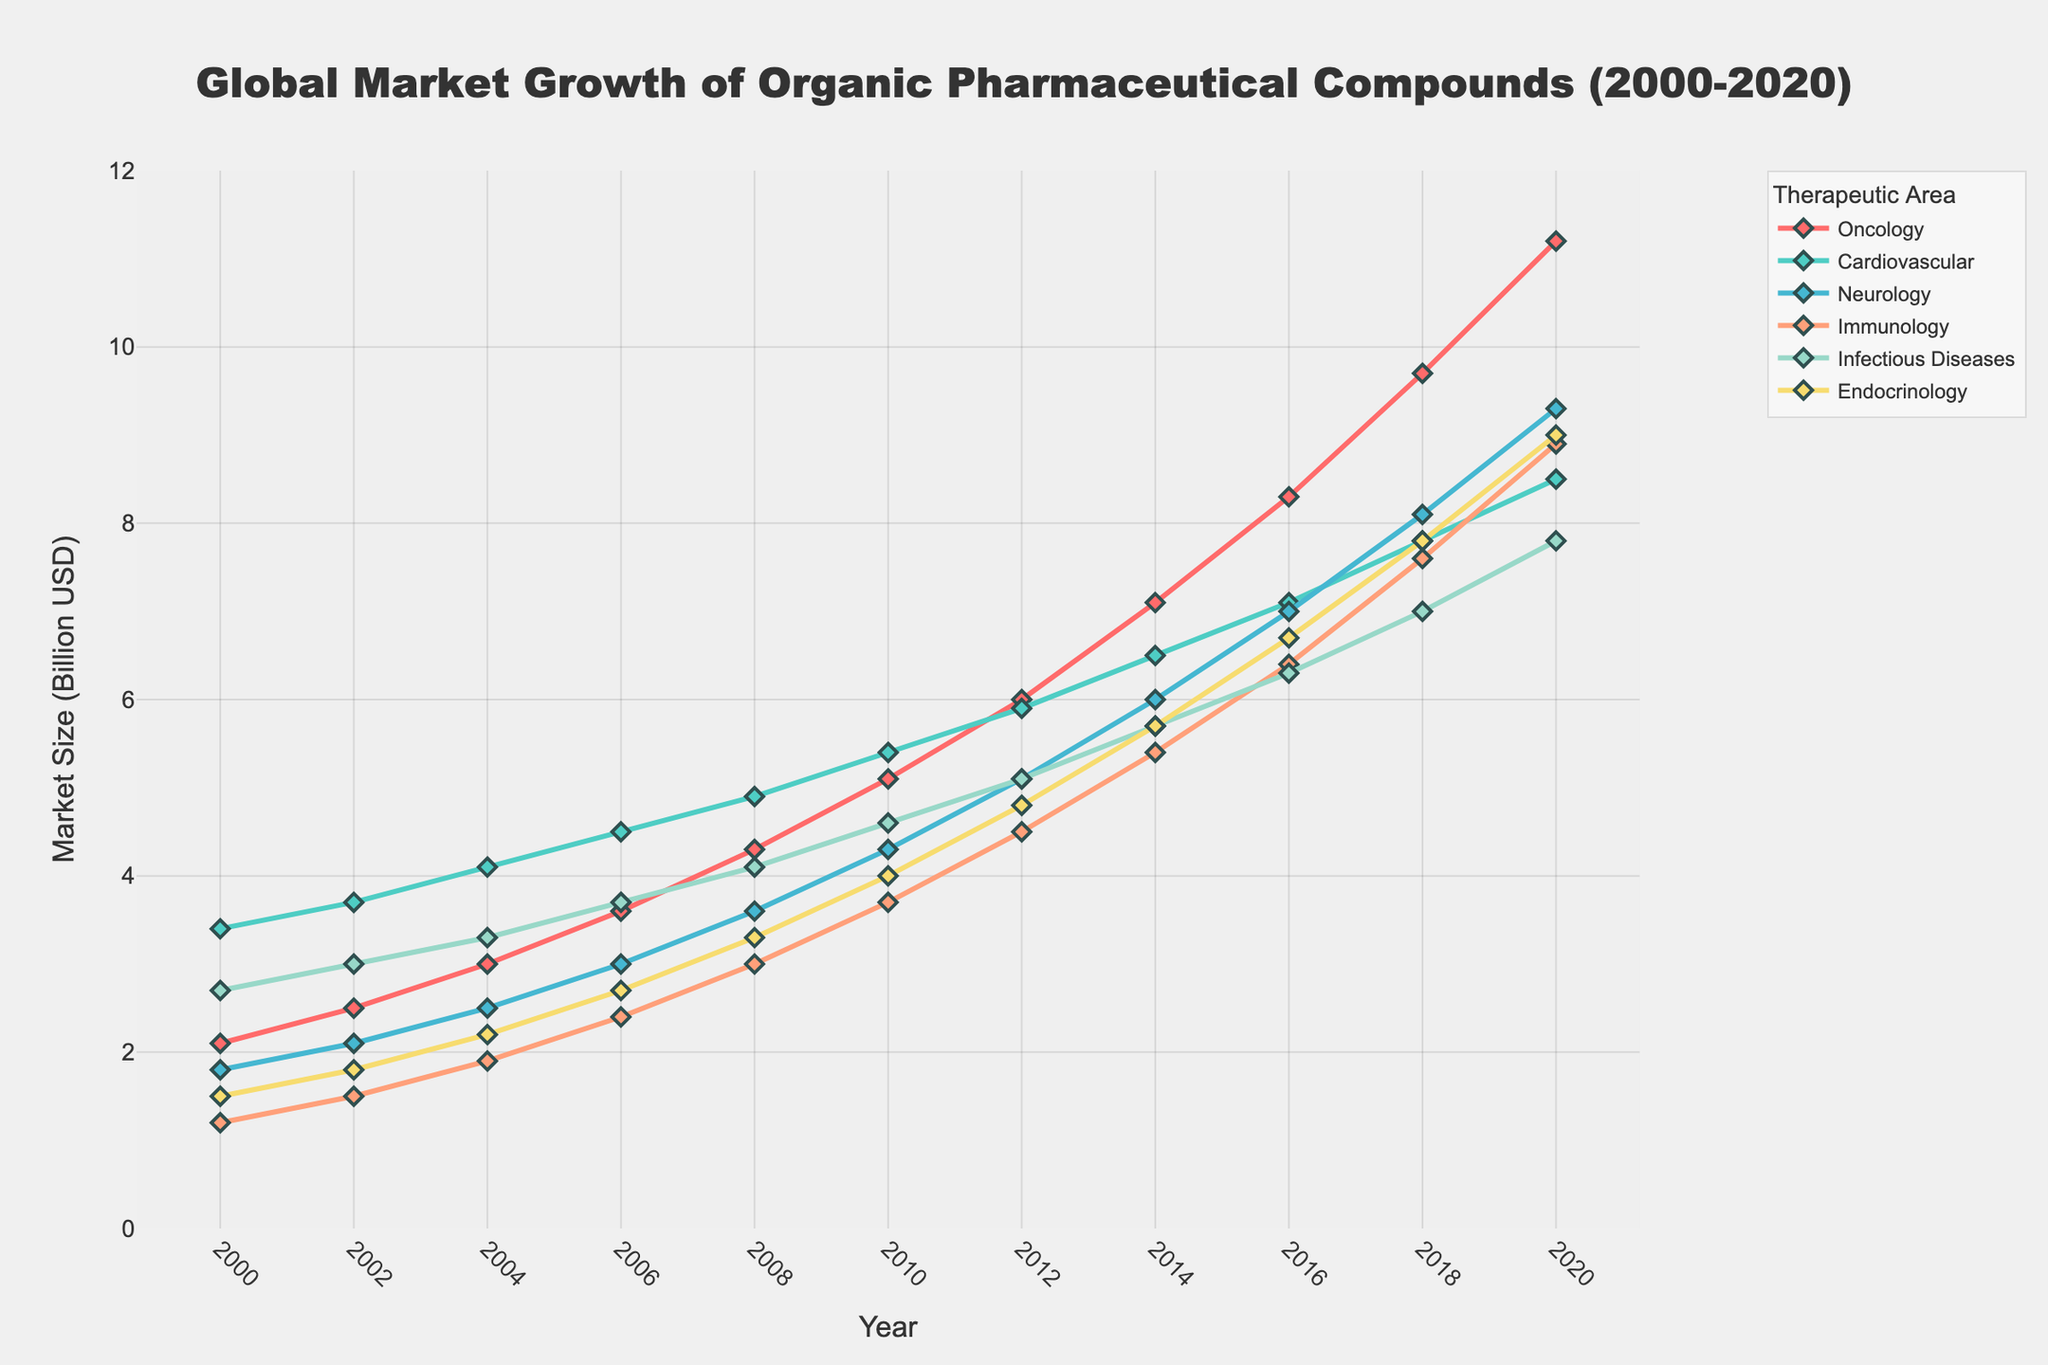What's the overall trend in the market size for Oncology from 2000 to 2020? The market size for Oncology shows a continuous upward trend from 2.1 billion USD in 2000 to 11.2 billion USD in 2020. This indicates a consistent growth over the 20 years.
Answer: Continuous upward trend Which therapeutic area had the lowest market size in 2010? By examining the figure, Immunology had the lowest market size in 2010 among all the therapeutic areas, with a value of 3.7 billion USD.
Answer: Immunology How does the growth rate of Cardiovascular compare to that of Neurology from 2000 to 2020? The market size for Cardiovascular increased from 3.4 billion USD in 2000 to 8.5 billion USD in 2020, while Neurology increased from 1.8 billion USD to 9.3 billion USD in the same period. Neurology's growth rate is higher than Cardiovascular's.
Answer: Neurology's growth rate is higher Which therapeutic area had the most significant increase in market size between 2000 and 2020? Oncology showed the most significant increase in market size, rising from 2.1 billion USD in 2000 to 11.2 billion USD in 2020. The increase is 9.1 billion USD over the period.
Answer: Oncology Which therapeutic area had the lowest market size increase from 2000 to 2020? Endocrinology had the lowest market size increase, growing from 1.5 billion USD in 2000 to 9.0 billion USD in 2020. The increase is 7.5 billion USD over the period.
Answer: Endocrinology What is the visual pattern of the market size for Infectious Diseases from 2000 to 2020? The market size for Infectious Diseases shows a consistent upward trend, starting at 2.7 billion USD in 2000 and increasing to 7.8 billion USD in 2020. The growth is relatively steady over the period.
Answer: Consistent upward trend Compare the market sizes for Immunology and Cardiovascular in 2016. Which one is greater and by how much? In 2016, the market size for Immunology is 6.4 billion USD and for Cardiovascular is 7.1 billion USD. Cardiovascular is greater by 0.7 billion USD.
Answer: Cardiovascular by 0.7 billion USD What is the average market size for Neurology from 2000 to 2020? The market sizes for Neurology from 2000 to 2020 are 1.8, 2.1, 2.5, 3.0, 3.6, 4.3, 5.1, 6.0, 7.0, 8.1, and 9.3 billion USD. The sum is 52.8 billion USD over 11 data points, so the average is 52.8 / 11 = 4.8 billion USD.
Answer: 4.8 billion USD In 2020, which therapeutic area had the second highest market size, and what was the value? In 2020, the second highest market size was for Neurology, with a value of 9.3 billion USD, after Oncology.
Answer: Neurology, 9.3 billion USD How much did the market size for Endocrinology grow from 2008 to 2014? The market size for Endocrinology grew from 3.3 billion USD in 2008 to 5.7 billion USD in 2014, which is an increase of 5.7 - 3.3 = 2.4 billion USD.
Answer: 2.4 billion USD 